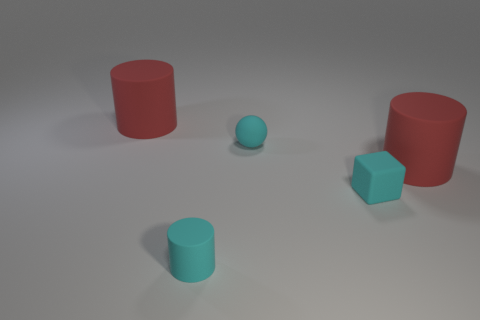Subtract all large cylinders. How many cylinders are left? 1 Subtract all blue spheres. How many red cylinders are left? 2 Add 4 cyan blocks. How many objects exist? 9 Subtract 1 cylinders. How many cylinders are left? 2 Subtract all cubes. How many objects are left? 4 Subtract all blue cylinders. Subtract all blue spheres. How many cylinders are left? 3 Subtract all big matte things. Subtract all cyan cylinders. How many objects are left? 2 Add 3 small cyan balls. How many small cyan balls are left? 4 Add 2 spheres. How many spheres exist? 3 Subtract 2 red cylinders. How many objects are left? 3 